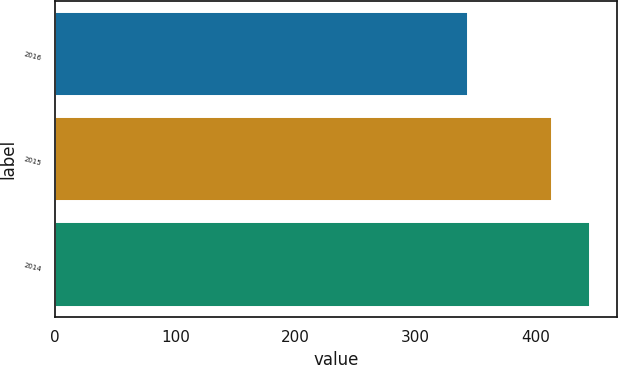<chart> <loc_0><loc_0><loc_500><loc_500><bar_chart><fcel>2016<fcel>2015<fcel>2014<nl><fcel>343.7<fcel>413.7<fcel>445.3<nl></chart> 